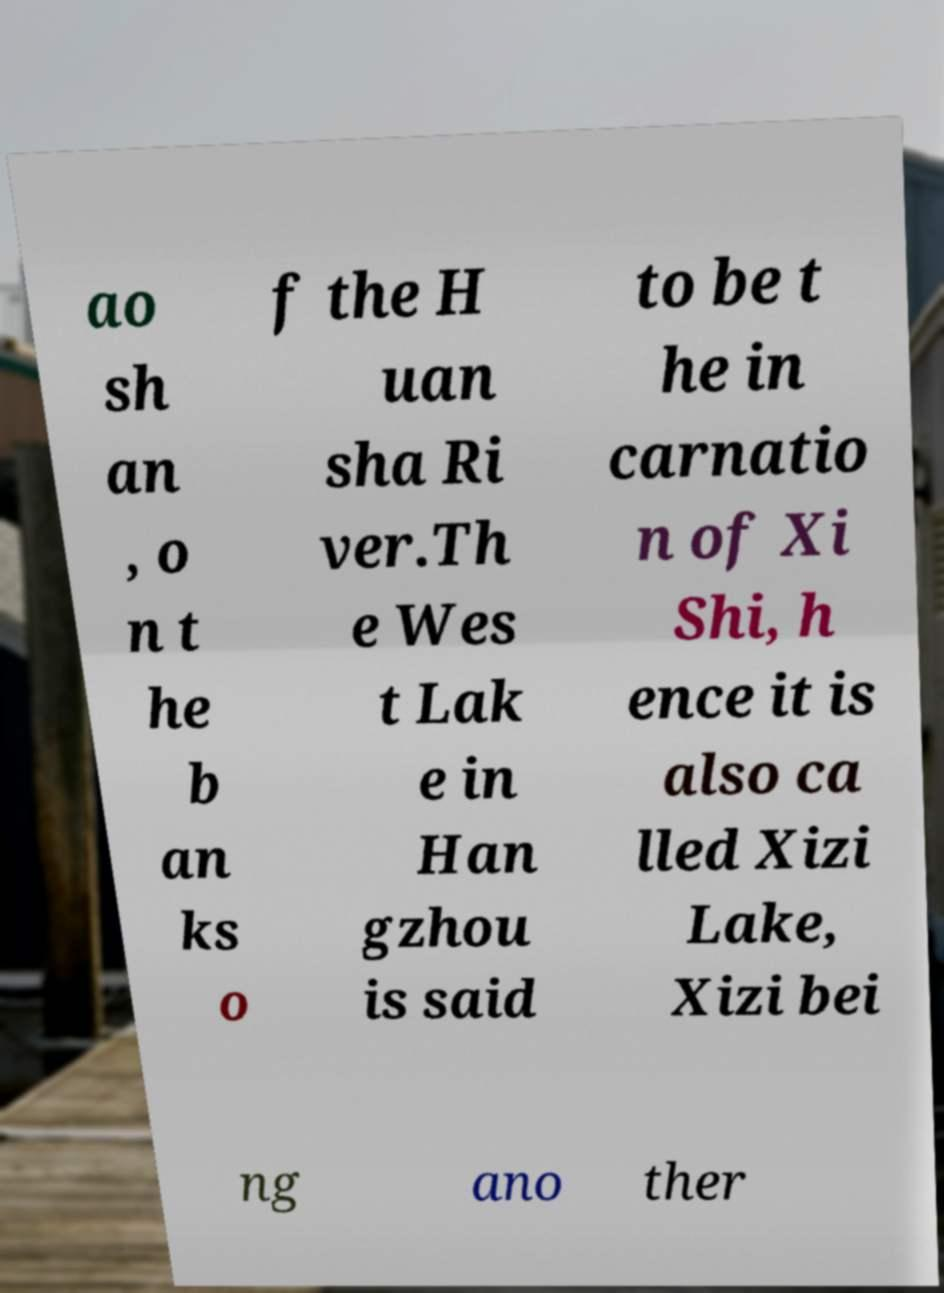Please read and relay the text visible in this image. What does it say? ao sh an , o n t he b an ks o f the H uan sha Ri ver.Th e Wes t Lak e in Han gzhou is said to be t he in carnatio n of Xi Shi, h ence it is also ca lled Xizi Lake, Xizi bei ng ano ther 